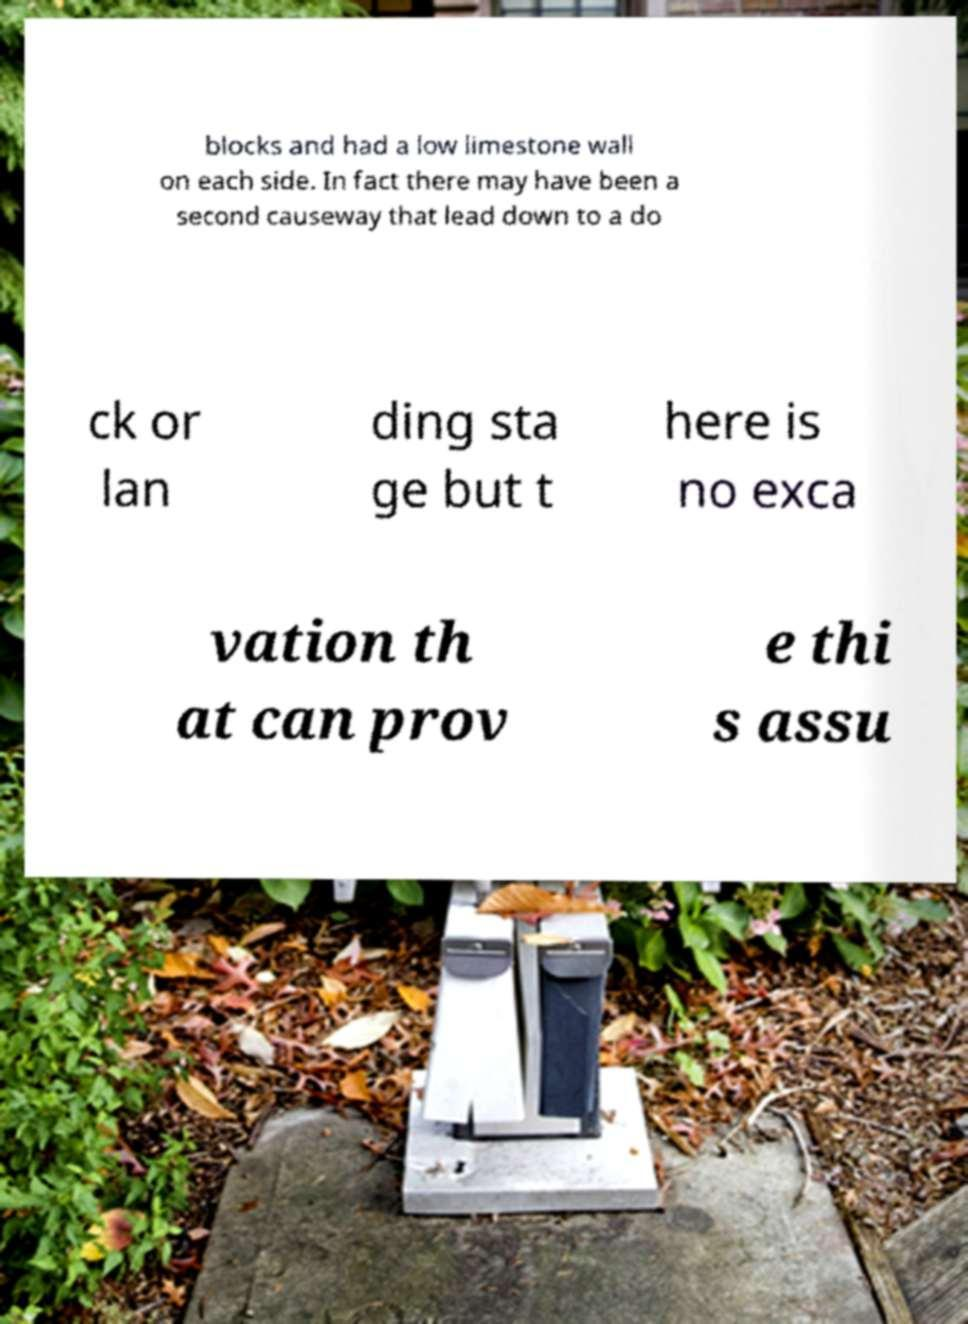Could you extract and type out the text from this image? blocks and had a low limestone wall on each side. In fact there may have been a second causeway that lead down to a do ck or lan ding sta ge but t here is no exca vation th at can prov e thi s assu 